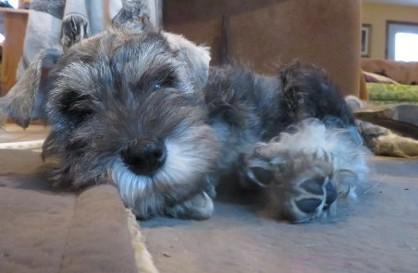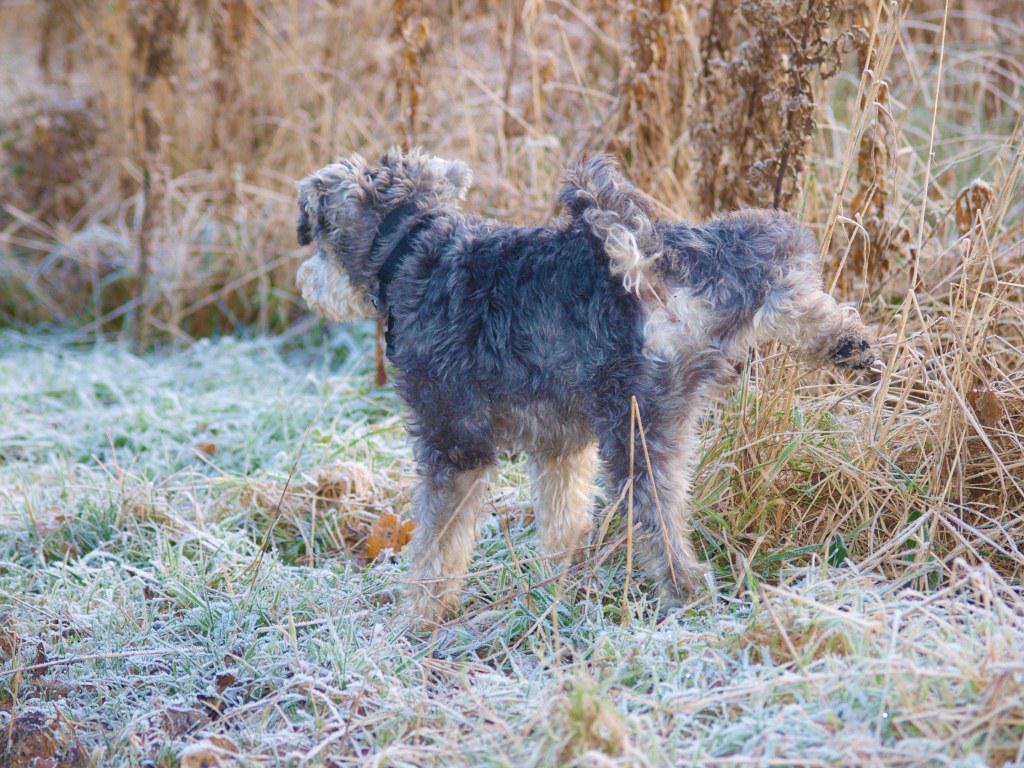The first image is the image on the left, the second image is the image on the right. Analyze the images presented: Is the assertion "There is an all white dog laying down." valid? Answer yes or no. No. The first image is the image on the left, the second image is the image on the right. Analyze the images presented: Is the assertion "A dog is sitting in one picture and in the other picture ta dog is lying down and asleep." valid? Answer yes or no. No. 